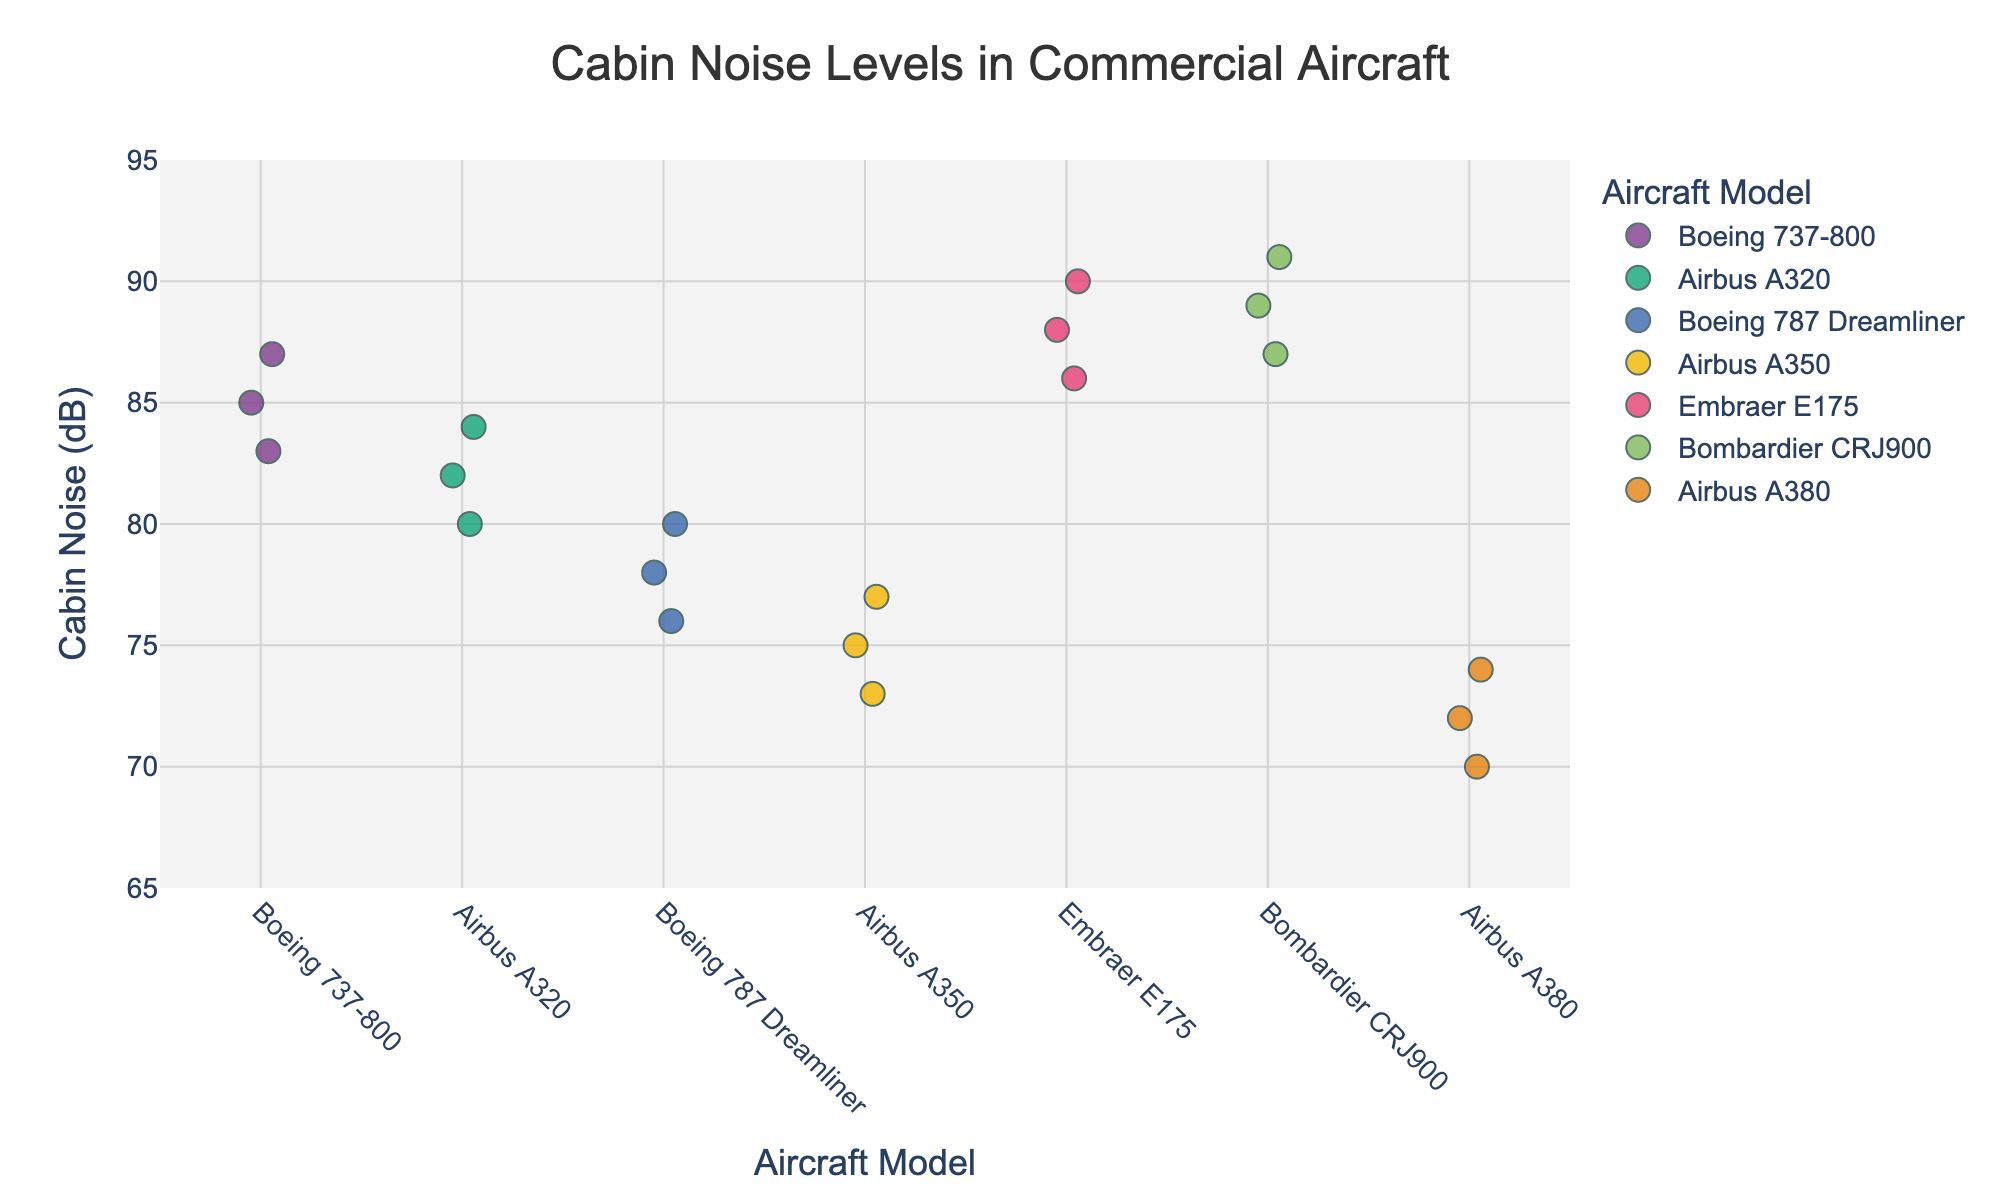What is the title of the plot? The title can be found at the top of the plot.
Answer: Cabin Noise Levels in Commercial Aircraft Which aircraft model has the lowest cabin noise level? Locate the point with the lowest y-axis value, representing the lowest decibel reading, and see which model it corresponds to.
Answer: Airbus A380 How many data points are there for the Boeing 737-800 model? Count the number of points aligned vertically under the "Boeing 737-800" label on the x-axis.
Answer: 3 Which aircraft model has the highest average cabin noise level? Calculate the average noise level for each model and compare them. Average for each model: Boeing 737-800 (85), Airbus A320 (82), Boeing 787 Dreamliner (78), Airbus A350 (75), Embraer E175 (88), Bombardier CRJ900 (89), Airbus A380 (72).
Answer: Bombardier CRJ900 How does the average cabin noise level of the Airbus A320 compare to that of the Boeing 787 Dreamliner? Calculate the average noise level for both models and compare them. Airbus A320: (82 + 80 + 84)/3 = 82. Boeing 787 Dreamliner: (78 + 76 + 80)/3 = 78.
Answer: Airbus A320 has a higher average noise level than the Boeing 787 Dreamliner What is the range of cabin noise levels for the Airbus A380? Identify the minimum and maximum values for the Airbus A380 and find the range by subtracting the minimum from the maximum.
Answer: 74 - 70 = 4 dB Which aircraft models have maximum cabin noise levels above 85 dB? Look for the highest points in each group on the plot and check which of them are above 85 dB.
Answer: Boeing 737-800, Embraer E175, Bombardier CRJ900 Between the Boeing 787 Dreamliner and Airbus A350, which model has more consistent cabin noise levels (smaller spread)? Compare the spread of points around the mean for each model. The narrower the spread, the more consistent the noise levels.
Answer: Airbus A350 What is the median cabin noise level for Bombardier CRJ900? Rank the Bombardier CRJ900 noise levels in ascending order (87, 89, 91) and find the middle value, which is the median.
Answer: 89 dB 